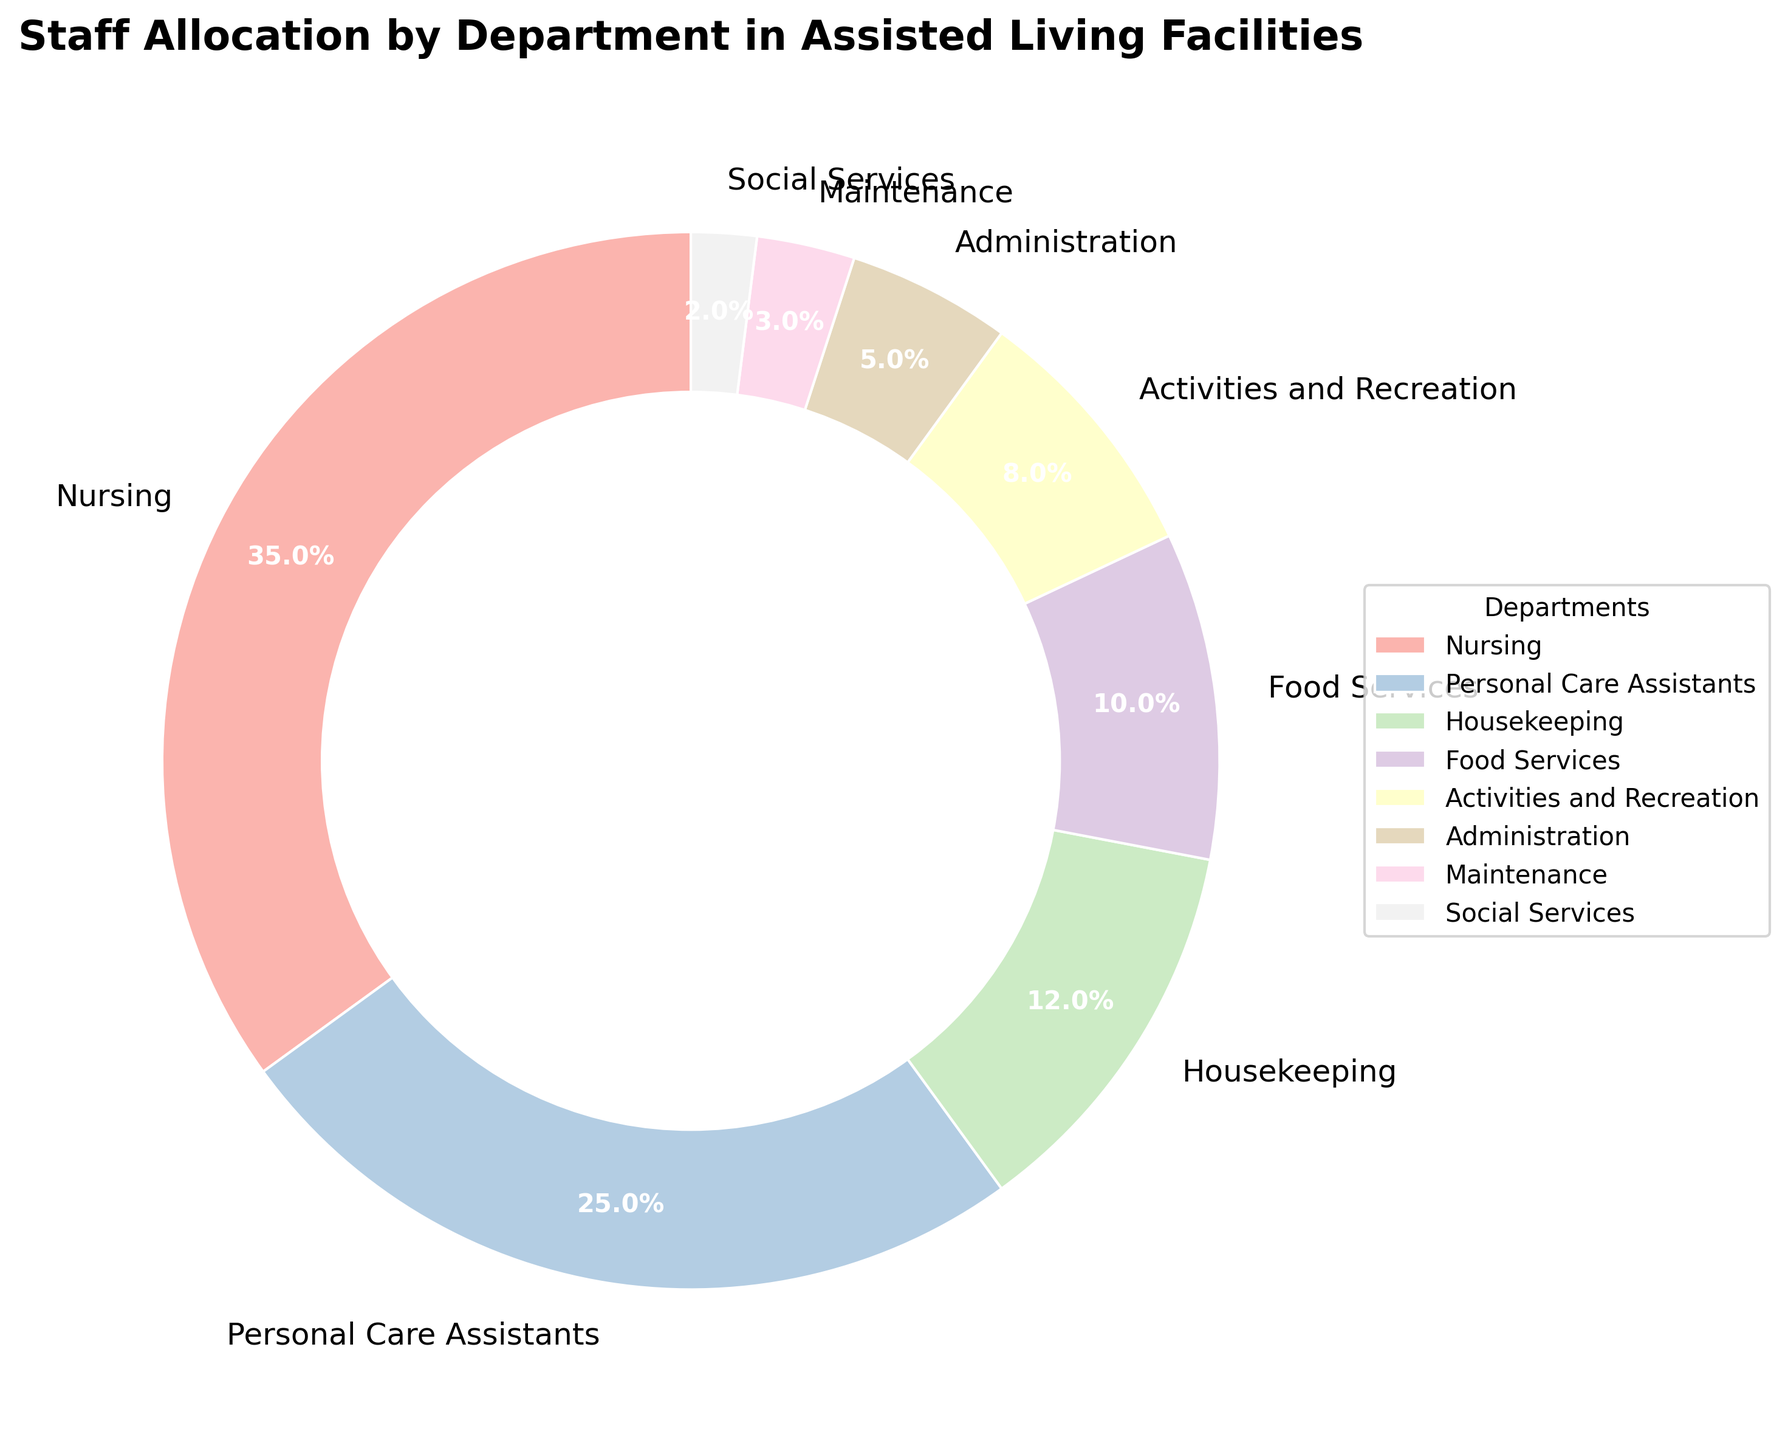What is the total percentage of staff allocated to Nursing and Personal Care Assistants combined? To find the total percentage of staff in Nursing and Personal Care Assistants, sum the percentages of both departments. Nursing has 35% and Personal Care Assistants have 25%. So, 35% + 25% = 60%.
Answer: 60% Which department has the smallest allocation of staff percentage? Based on the pie chart, the department with the smallest portion is Social Services at 2%.
Answer: Social Services What is the difference in staff allocation percentage between Housekeeping and Administration? To find the difference, subtract the percentage of staff in Administration from the percentage of staff in Housekeeping. Housekeeping is 12% and Administration is 5%, so 12% - 5% = 7%.
Answer: 7% Which department has a higher staff allocation, Maintenance or Food Services, and by how much? Comparing the percentages, Food Services has 10% while Maintenance has 3%. To find how much higher Food Services is, subtract 3% from 10%, which gives 10% - 3% = 7%.
Answer: Food Services, 7% What percentage of staff is allocated to departments related to patient care (Nursing, Personal Care Assistants, and Social Services)? To find this, sum the percentages of Nursing, Personal Care Assistants, and Social Services. This is 35% + 25% + 2% = 62%.
Answer: 62% Among Housekeeping, Food Services, and Activities and Recreation, which department has the largest staff allocation? Comparing the percentages of these departments: Housekeeping is 12%, Food Services is 10%, and Activities and Recreation is 8%. Housekeeping has the largest allocation at 12%.
Answer: Housekeeping How much larger is the Nursing department's staff allocation compared to Social Services? Subtract the percentage allocated to Social Services from the percentage allocated to Nursing. Nursing is 35% and Social Services is 2%, so 35% - 2% = 33%.
Answer: 33% Which has a larger staff allocation: the combination of Administration and Maintenance or Personal Care Assistants? First, sum the percentages for Administration and Maintenance: 5% + 3% = 8%. Personal Care Assistants have 25%. Since 25% is larger than 8%, Personal Care Assistants have a larger allocation.
Answer: Personal Care Assistants What are the combined staff percentages for Housekeeping and Food Services departments? Summing the percentages for Housekeeping and Food Services: 12% + 10% = 22%.
Answer: 22% Does the sum of the percentages for Food Services and Activities and Recreation equal the staff percentage allocated to Housekeeping? Adding the percentages for Food Services (10%) and Activities and Recreation (8%) gives 10% + 8% = 18%. Housekeeping is allocated 12%, so the sums are not equal.
Answer: No 